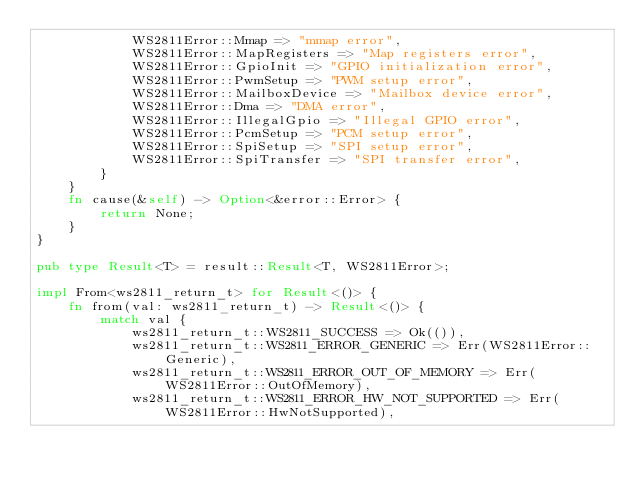Convert code to text. <code><loc_0><loc_0><loc_500><loc_500><_Rust_>            WS2811Error::Mmap => "mmap error",
            WS2811Error::MapRegisters => "Map registers error",
            WS2811Error::GpioInit => "GPIO initialization error",
            WS2811Error::PwmSetup => "PWM setup error",
            WS2811Error::MailboxDevice => "Mailbox device error",
            WS2811Error::Dma => "DMA error",
            WS2811Error::IllegalGpio => "Illegal GPIO error",
            WS2811Error::PcmSetup => "PCM setup error",
            WS2811Error::SpiSetup => "SPI setup error",
            WS2811Error::SpiTransfer => "SPI transfer error",
        }
    }
    fn cause(&self) -> Option<&error::Error> {
        return None;
    }
}

pub type Result<T> = result::Result<T, WS2811Error>;

impl From<ws2811_return_t> for Result<()> {
    fn from(val: ws2811_return_t) -> Result<()> {
        match val {
            ws2811_return_t::WS2811_SUCCESS => Ok(()),
            ws2811_return_t::WS2811_ERROR_GENERIC => Err(WS2811Error::Generic),
            ws2811_return_t::WS2811_ERROR_OUT_OF_MEMORY => Err(WS2811Error::OutOfMemory),
            ws2811_return_t::WS2811_ERROR_HW_NOT_SUPPORTED => Err(WS2811Error::HwNotSupported),</code> 